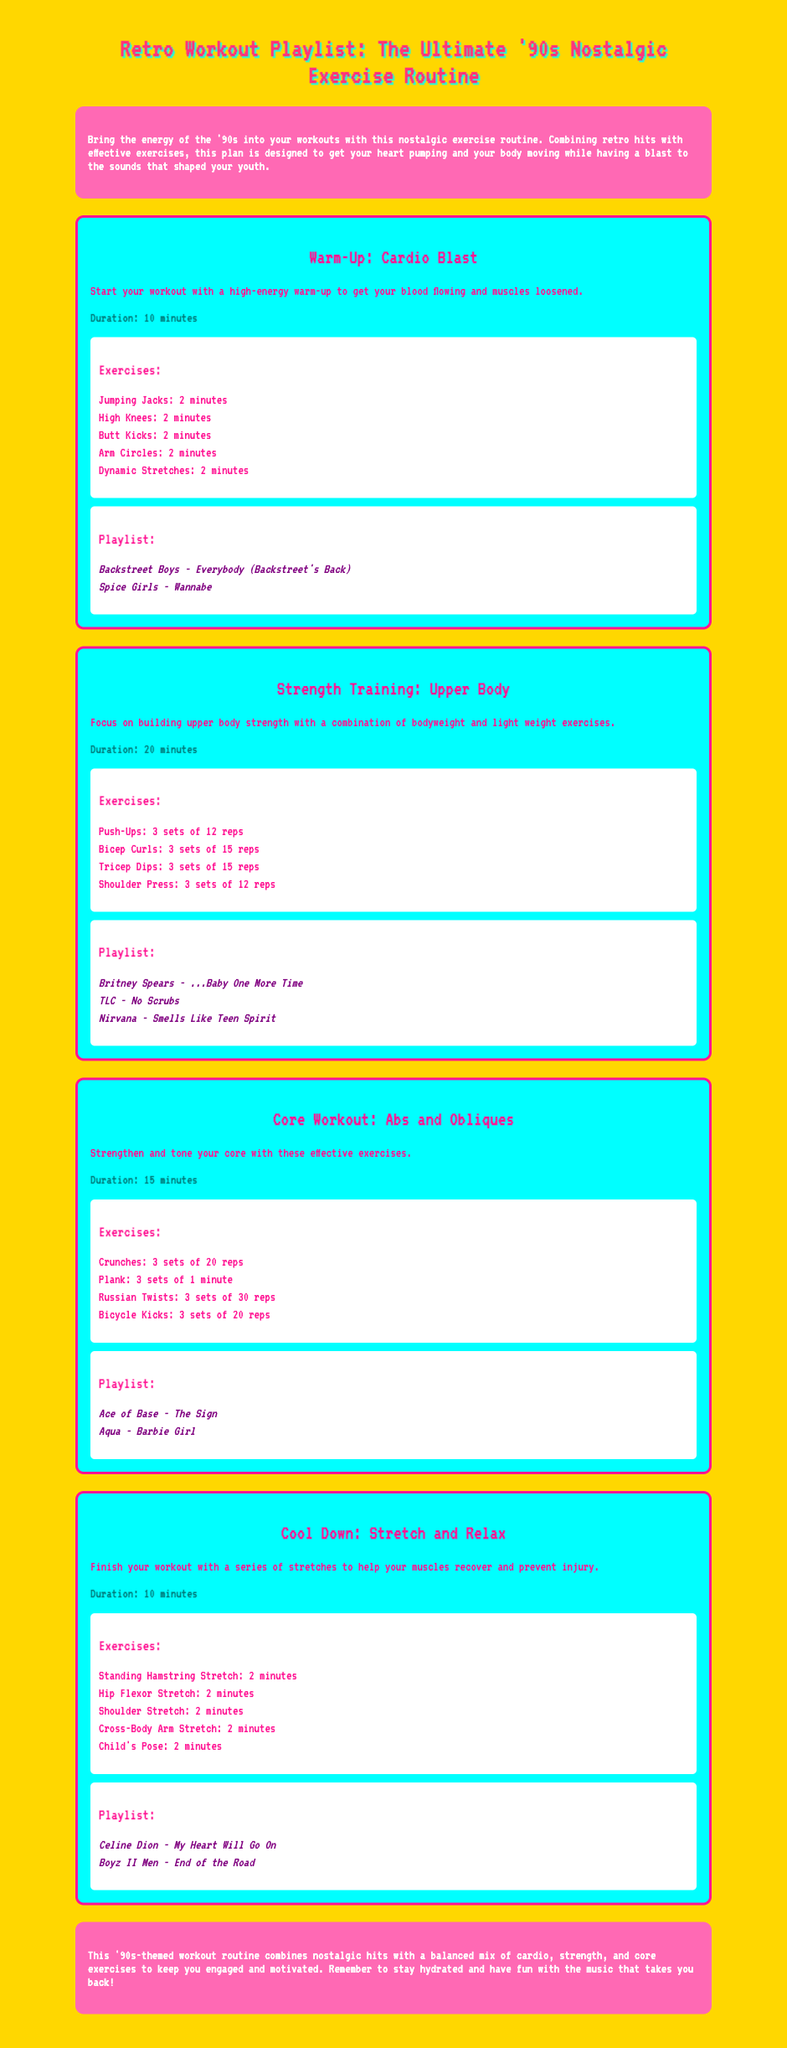What is the duration of the Warm-Up session? The duration of the Warm-Up session is mentioned in the document, specifically noted as 10 minutes.
Answer: 10 minutes Which song by Britney Spears is included in the Strength Training session? The song included in the Strength Training session is mentioned explicitly in the playlist section of that session.
Answer: ...Baby One More Time How many exercises are listed for the Core Workout session? The number of exercises can be counted in the exercises section of the Core Workout session, which lists four specific exercises.
Answer: 4 What is the first exercise in the Cool Down session? The first exercise in the Cool Down session is detailed in the exercises list, which starts with the Standing Hamstring Stretch.
Answer: Standing Hamstring Stretch How long is the duration of the Strength Training session? The duration of the Strength Training session is clearly specified in the document, given as 20 minutes.
Answer: 20 minutes What kind of workout does the Core Workout session focus on? The focus of the Core Workout session is clearly described in the title and is aimed at strengthening and toning the core.
Answer: Abs and Obliques Which song from TLC is featured in the Strength Training playlist? The song from TLC included in the playlist for the Strength Training session is specifically noted in that section in the document.
Answer: No Scrubs What is the background color of the intro section? The background color of the intro section can be found in the styling details provided in the document, noted as pink.
Answer: Pink 